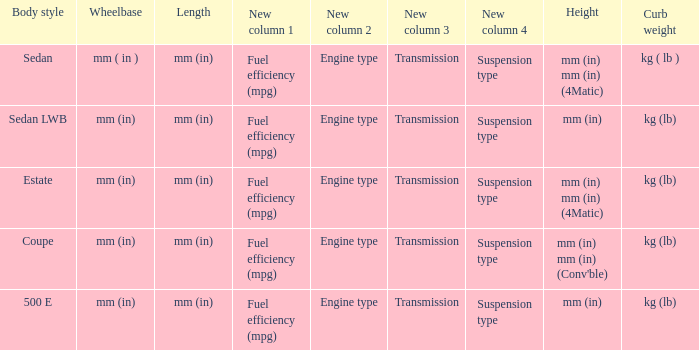What's the curb weight of the model with a wheelbase of mm (in) and height of mm (in) mm (in) (4Matic)? Kg ( lb ), kg (lb). 